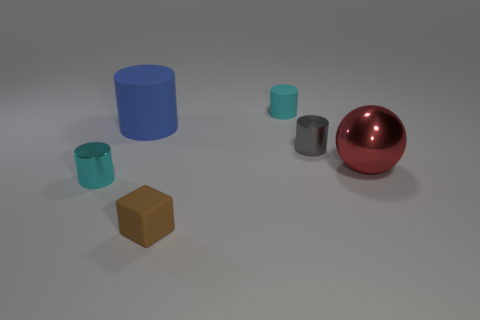There is a brown rubber object that is the same size as the cyan rubber thing; what shape is it?
Make the answer very short. Cube. Is the material of the small cyan cylinder behind the large cylinder the same as the large red sphere?
Ensure brevity in your answer.  No. Is the number of gray objects to the left of the tiny gray metal object greater than the number of tiny matte blocks behind the brown cube?
Your answer should be very brief. No. There is a gray cylinder that is the same size as the rubber cube; what is its material?
Provide a succinct answer. Metal. What number of other things are made of the same material as the blue cylinder?
Offer a very short reply. 2. Does the cyan thing in front of the large red metallic sphere have the same shape as the tiny matte object that is in front of the cyan matte thing?
Provide a short and direct response. No. How many other objects are there of the same color as the tiny matte cube?
Keep it short and to the point. 0. Is the tiny cyan cylinder that is in front of the tiny gray cylinder made of the same material as the small cylinder that is behind the gray thing?
Offer a terse response. No. Is the number of large balls that are right of the blue rubber object the same as the number of blue objects that are to the right of the tiny brown object?
Ensure brevity in your answer.  No. What material is the cyan cylinder behind the tiny gray shiny cylinder?
Provide a short and direct response. Rubber. 